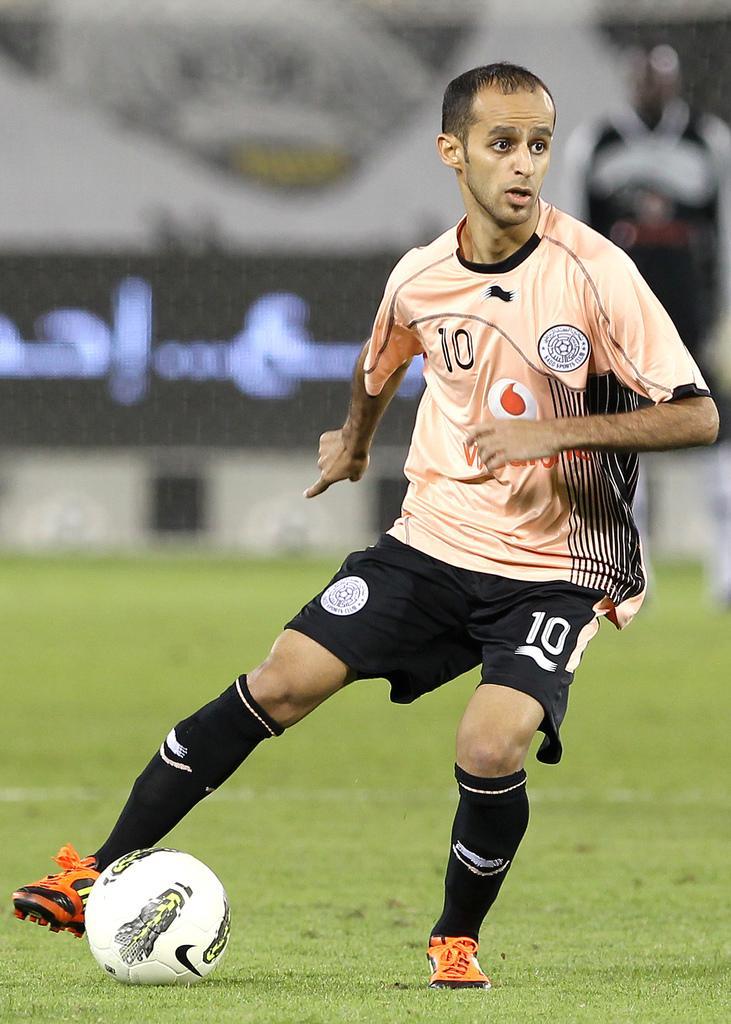Could you give a brief overview of what you see in this image? This picture shows a man playing football on the green field 